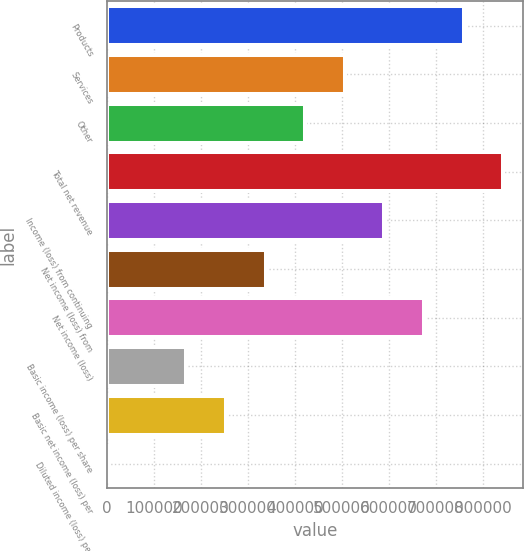Convert chart to OTSL. <chart><loc_0><loc_0><loc_500><loc_500><bar_chart><fcel>Products<fcel>Services<fcel>Other<fcel>Total net revenue<fcel>Income (loss) from continuing<fcel>Net income (loss) from<fcel>Net income (loss)<fcel>Basic income (loss) per share<fcel>Basic net income (loss) per<fcel>Diluted income (loss) per<nl><fcel>758610<fcel>505741<fcel>421451<fcel>842900<fcel>590031<fcel>337161<fcel>674320<fcel>168582<fcel>252871<fcel>1.92<nl></chart> 